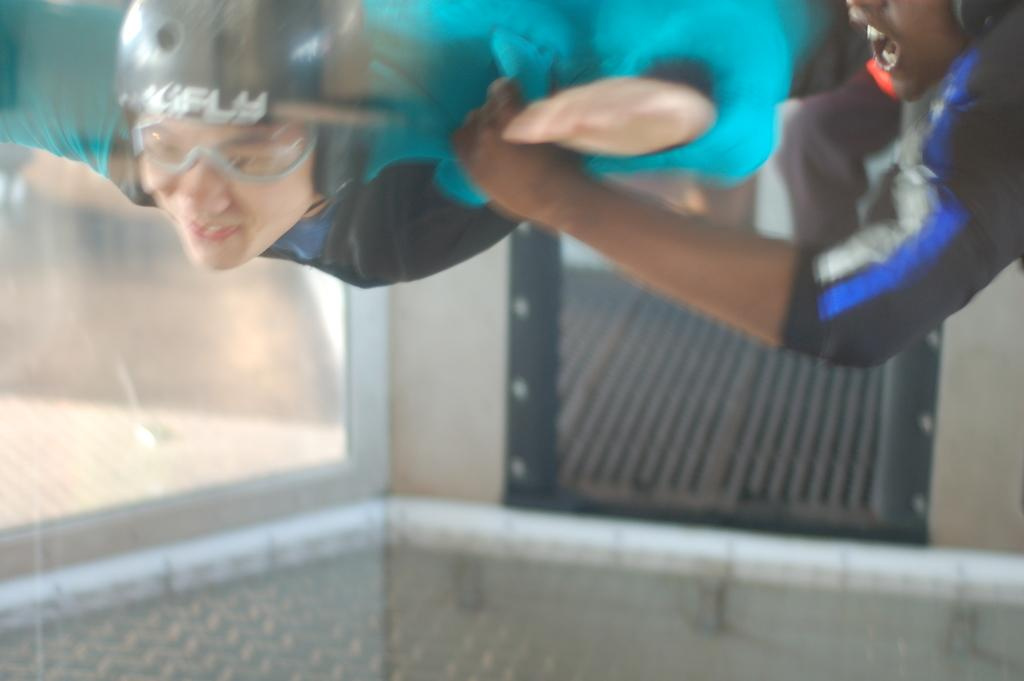Who is present in the image? There is a person in the image. What is the person wearing on their upper body? The person is wearing a blue coat. What type of eyewear is the person wearing? The person is wearing glasses. What type of headgear is the person wearing? The person is wearing a helmet. What can be seen on the left side of the image? There is a glass wall on the left side of the image. What book is the person reading in the image? There is no book present in the image. How many ducks are visible in the image? There are no ducks visible in the image. 